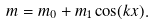<formula> <loc_0><loc_0><loc_500><loc_500>m = m _ { 0 } + m _ { 1 } \cos ( k x ) .</formula> 